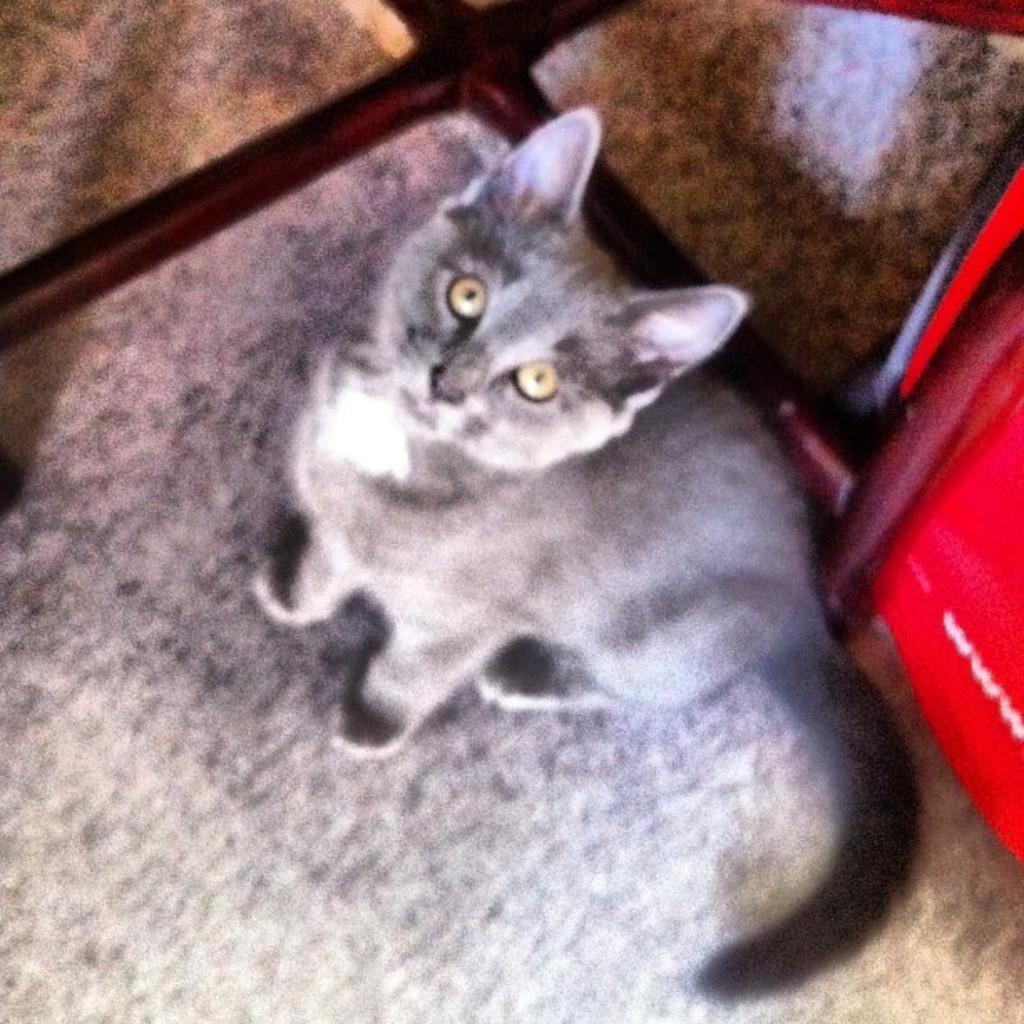In one or two sentences, can you explain what this image depicts? In this picture I can observe a cat sitting on the floor. The cat is in grey color and I can observe yellow color eyes of the cat. 